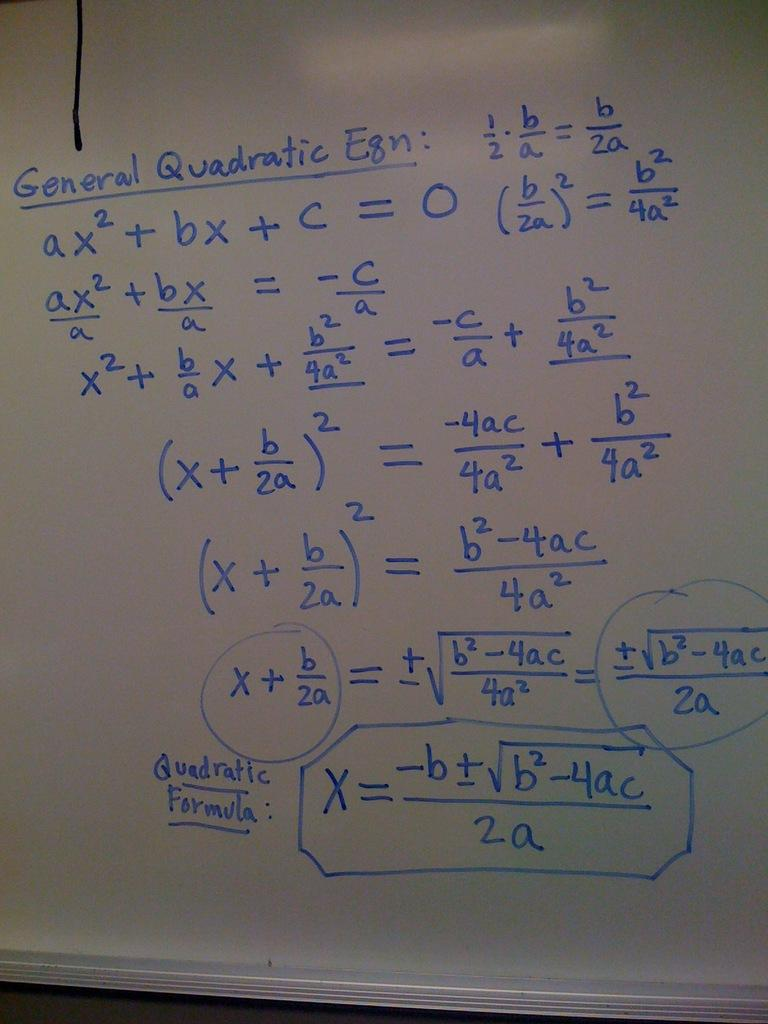Provide a one-sentence caption for the provided image. A chalkboard with complicated math problems on it. 